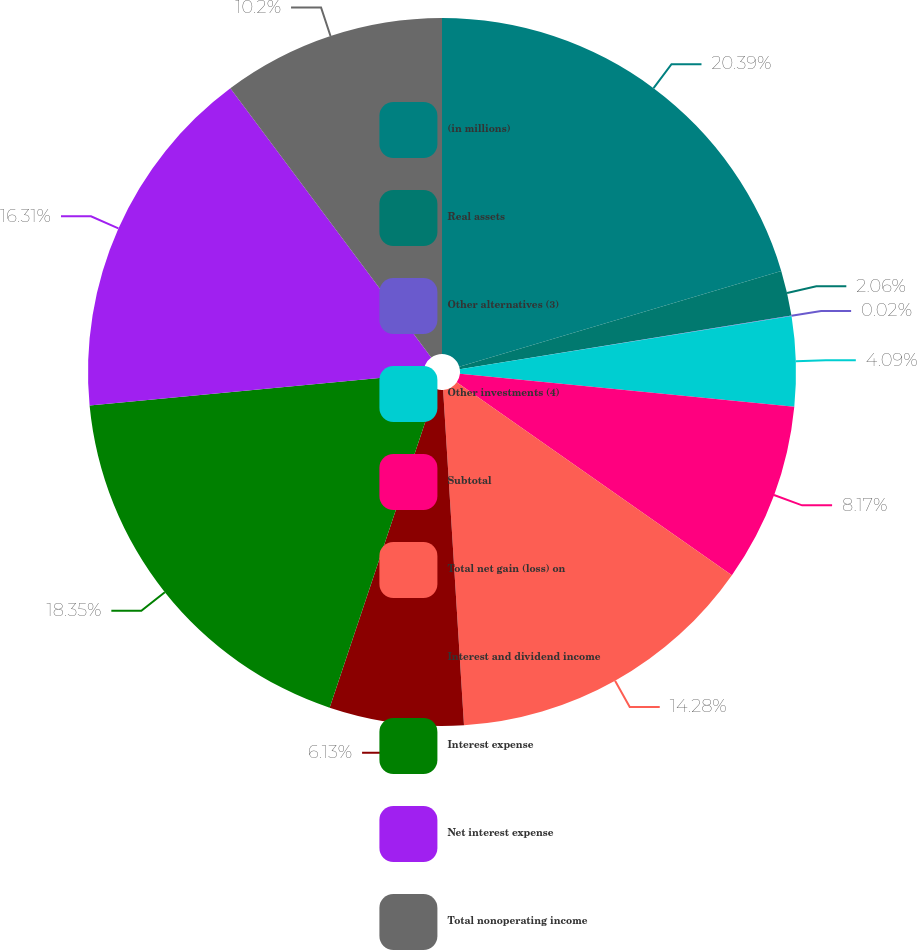<chart> <loc_0><loc_0><loc_500><loc_500><pie_chart><fcel>(in millions)<fcel>Real assets<fcel>Other alternatives (3)<fcel>Other investments (4)<fcel>Subtotal<fcel>Total net gain (loss) on<fcel>Interest and dividend income<fcel>Interest expense<fcel>Net interest expense<fcel>Total nonoperating income<nl><fcel>20.39%<fcel>2.06%<fcel>0.02%<fcel>4.09%<fcel>8.17%<fcel>14.28%<fcel>6.13%<fcel>18.35%<fcel>16.31%<fcel>10.2%<nl></chart> 